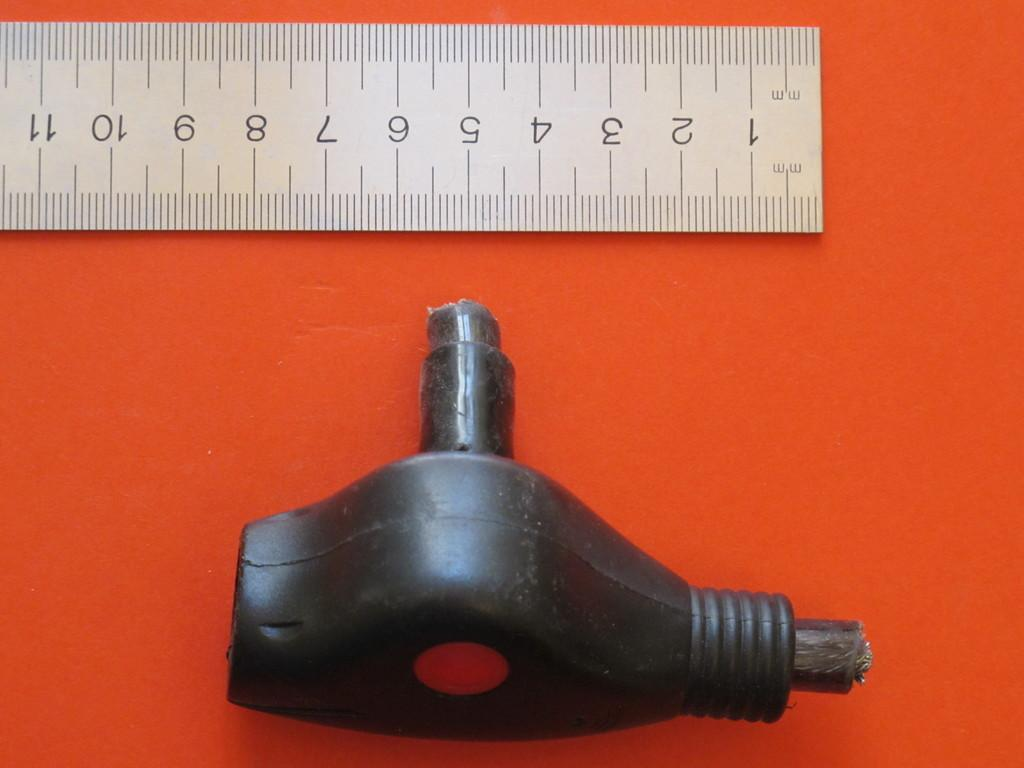Provide a one-sentence caption for the provided image. A ruler showing the numbers 1 through 11 with some sort of tool next to it. 